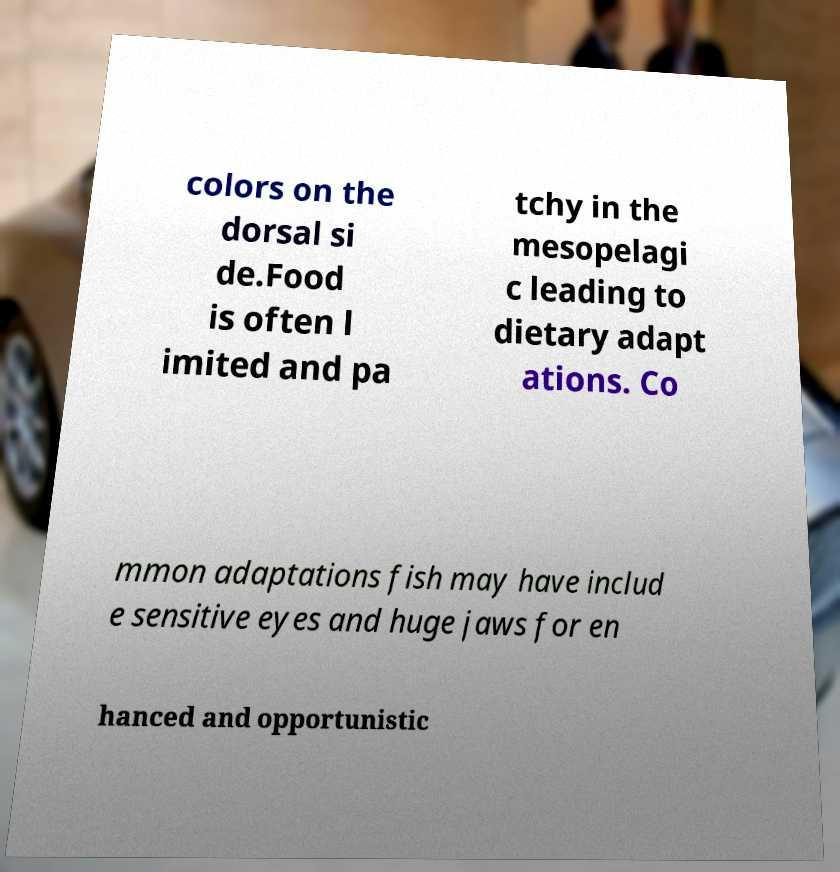Can you accurately transcribe the text from the provided image for me? colors on the dorsal si de.Food is often l imited and pa tchy in the mesopelagi c leading to dietary adapt ations. Co mmon adaptations fish may have includ e sensitive eyes and huge jaws for en hanced and opportunistic 